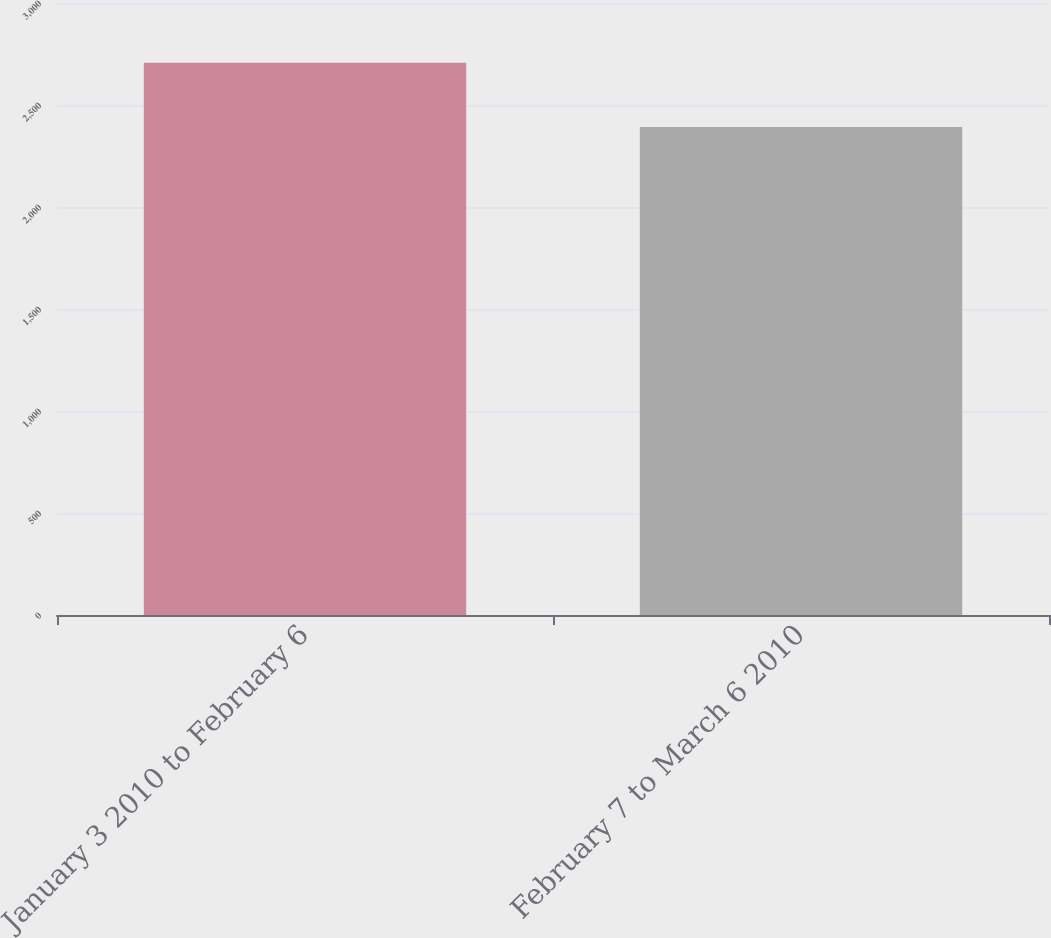Convert chart to OTSL. <chart><loc_0><loc_0><loc_500><loc_500><bar_chart><fcel>January 3 2010 to February 6<fcel>February 7 to March 6 2010<nl><fcel>2707<fcel>2392<nl></chart> 